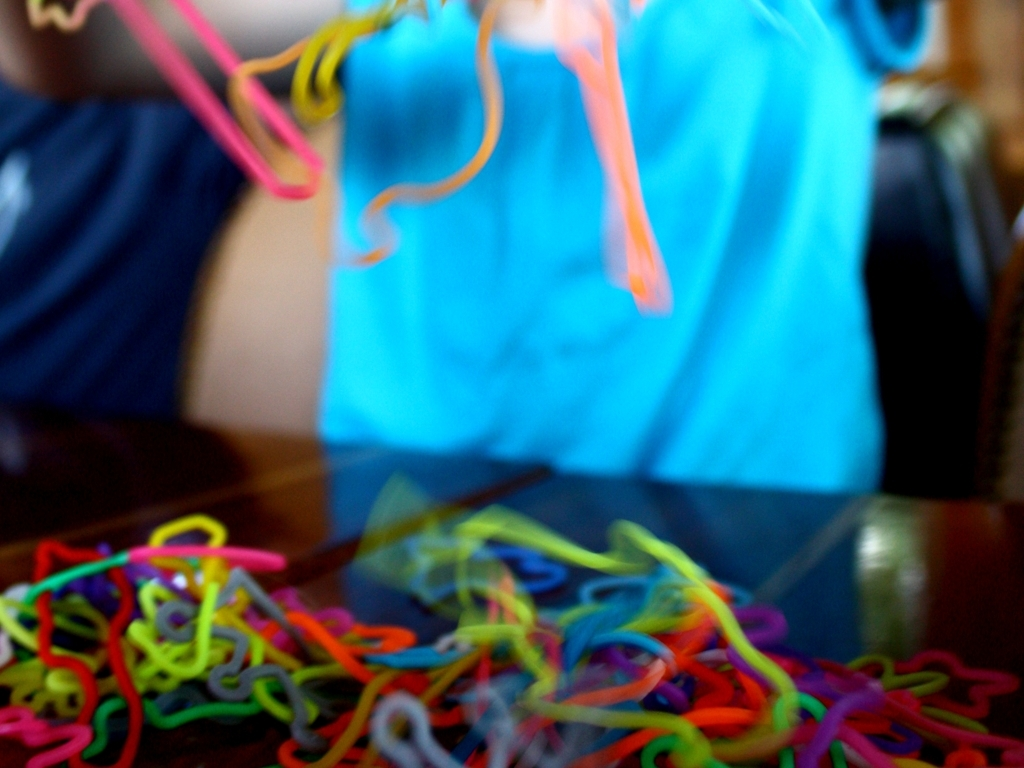What objects are these and what are they commonly used for? These appear to be colorful plastic loops, often known as 'linking loops' or 'learning loops'. They are often used as educational toys to teach children about colors, shapes, and motor skills as they link them together. 